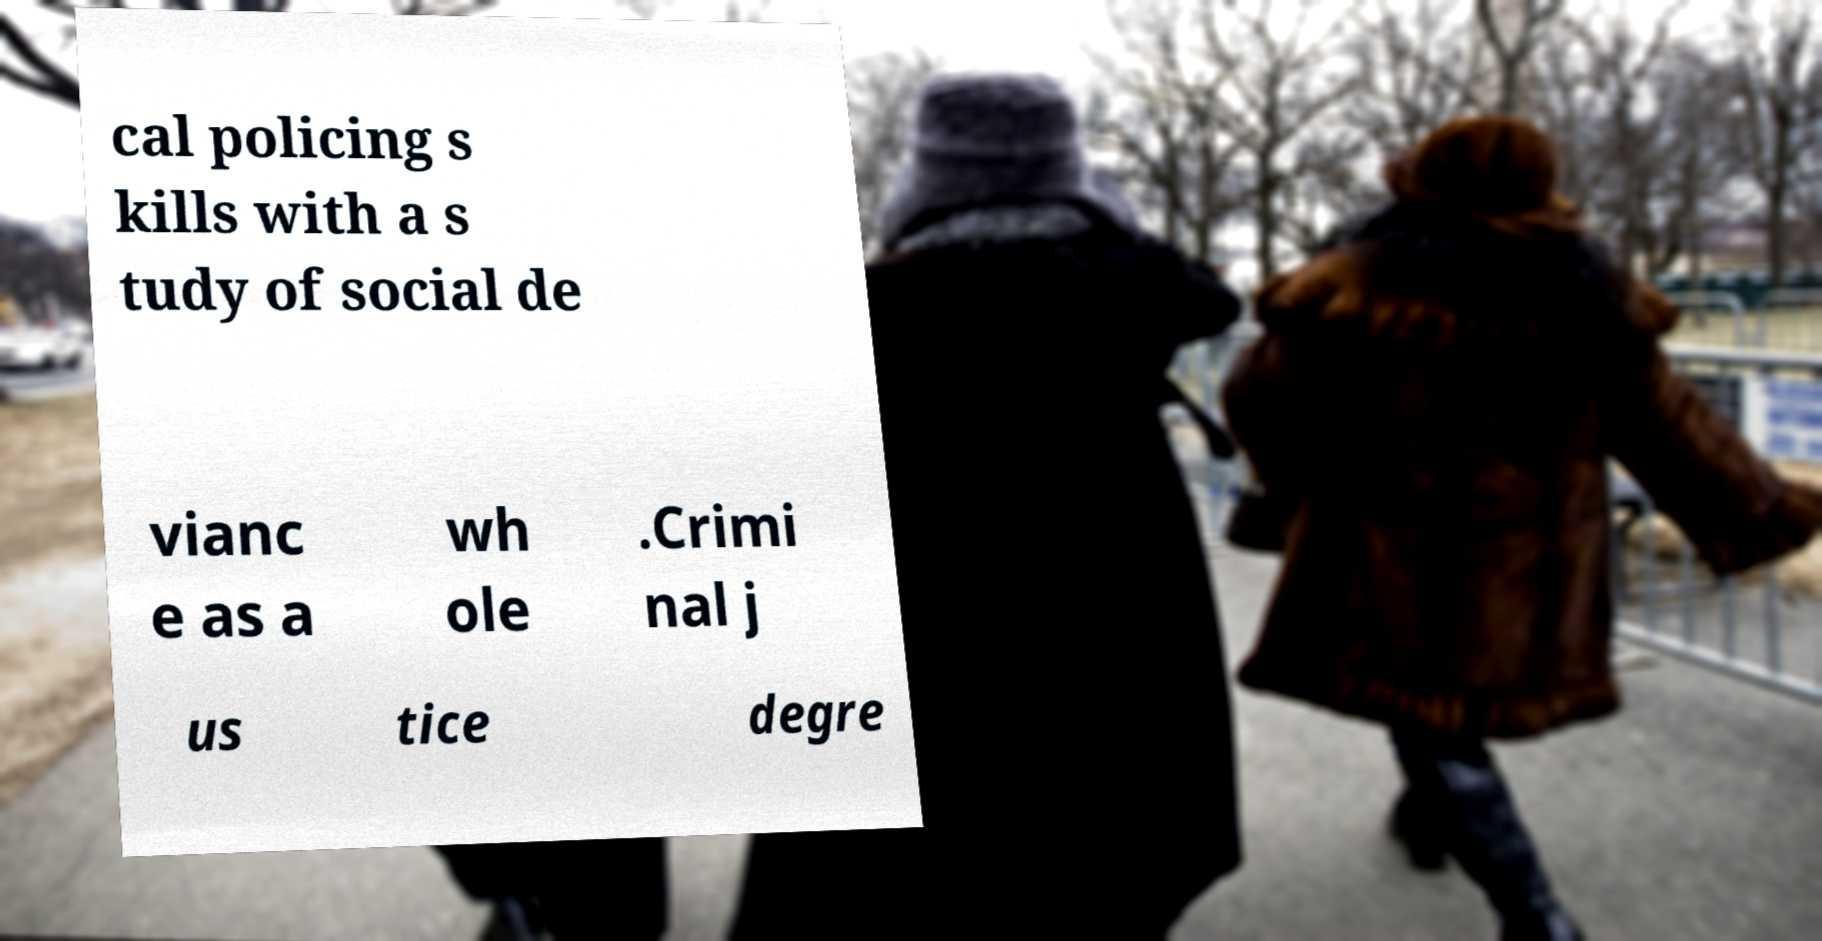Could you extract and type out the text from this image? cal policing s kills with a s tudy of social de vianc e as a wh ole .Crimi nal j us tice degre 